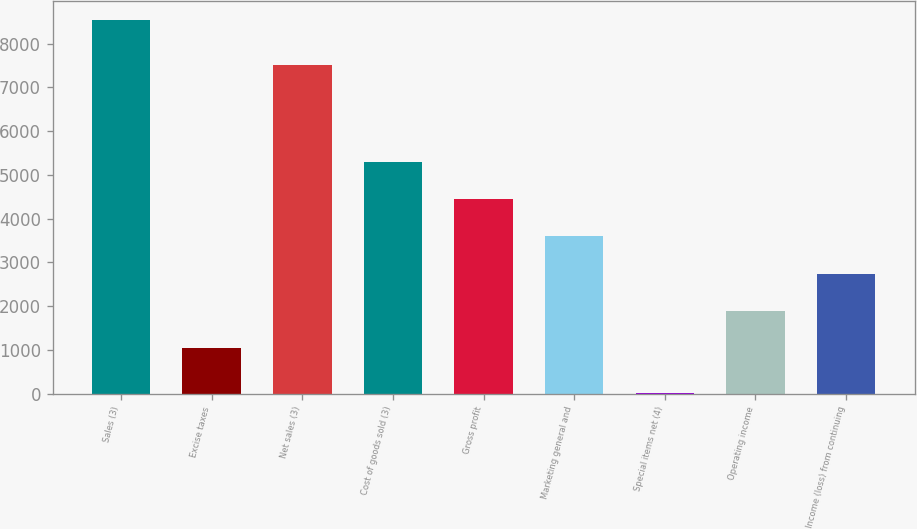Convert chart. <chart><loc_0><loc_0><loc_500><loc_500><bar_chart><fcel>Sales (3)<fcel>Excise taxes<fcel>Net sales (3)<fcel>Cost of goods sold (3)<fcel>Gross profit<fcel>Marketing general and<fcel>Special items net (4)<fcel>Operating income<fcel>Income (loss) from continuing<nl><fcel>8541.7<fcel>1036<fcel>7505.7<fcel>5301.9<fcel>4448.72<fcel>3595.54<fcel>9.9<fcel>1889.18<fcel>2742.36<nl></chart> 